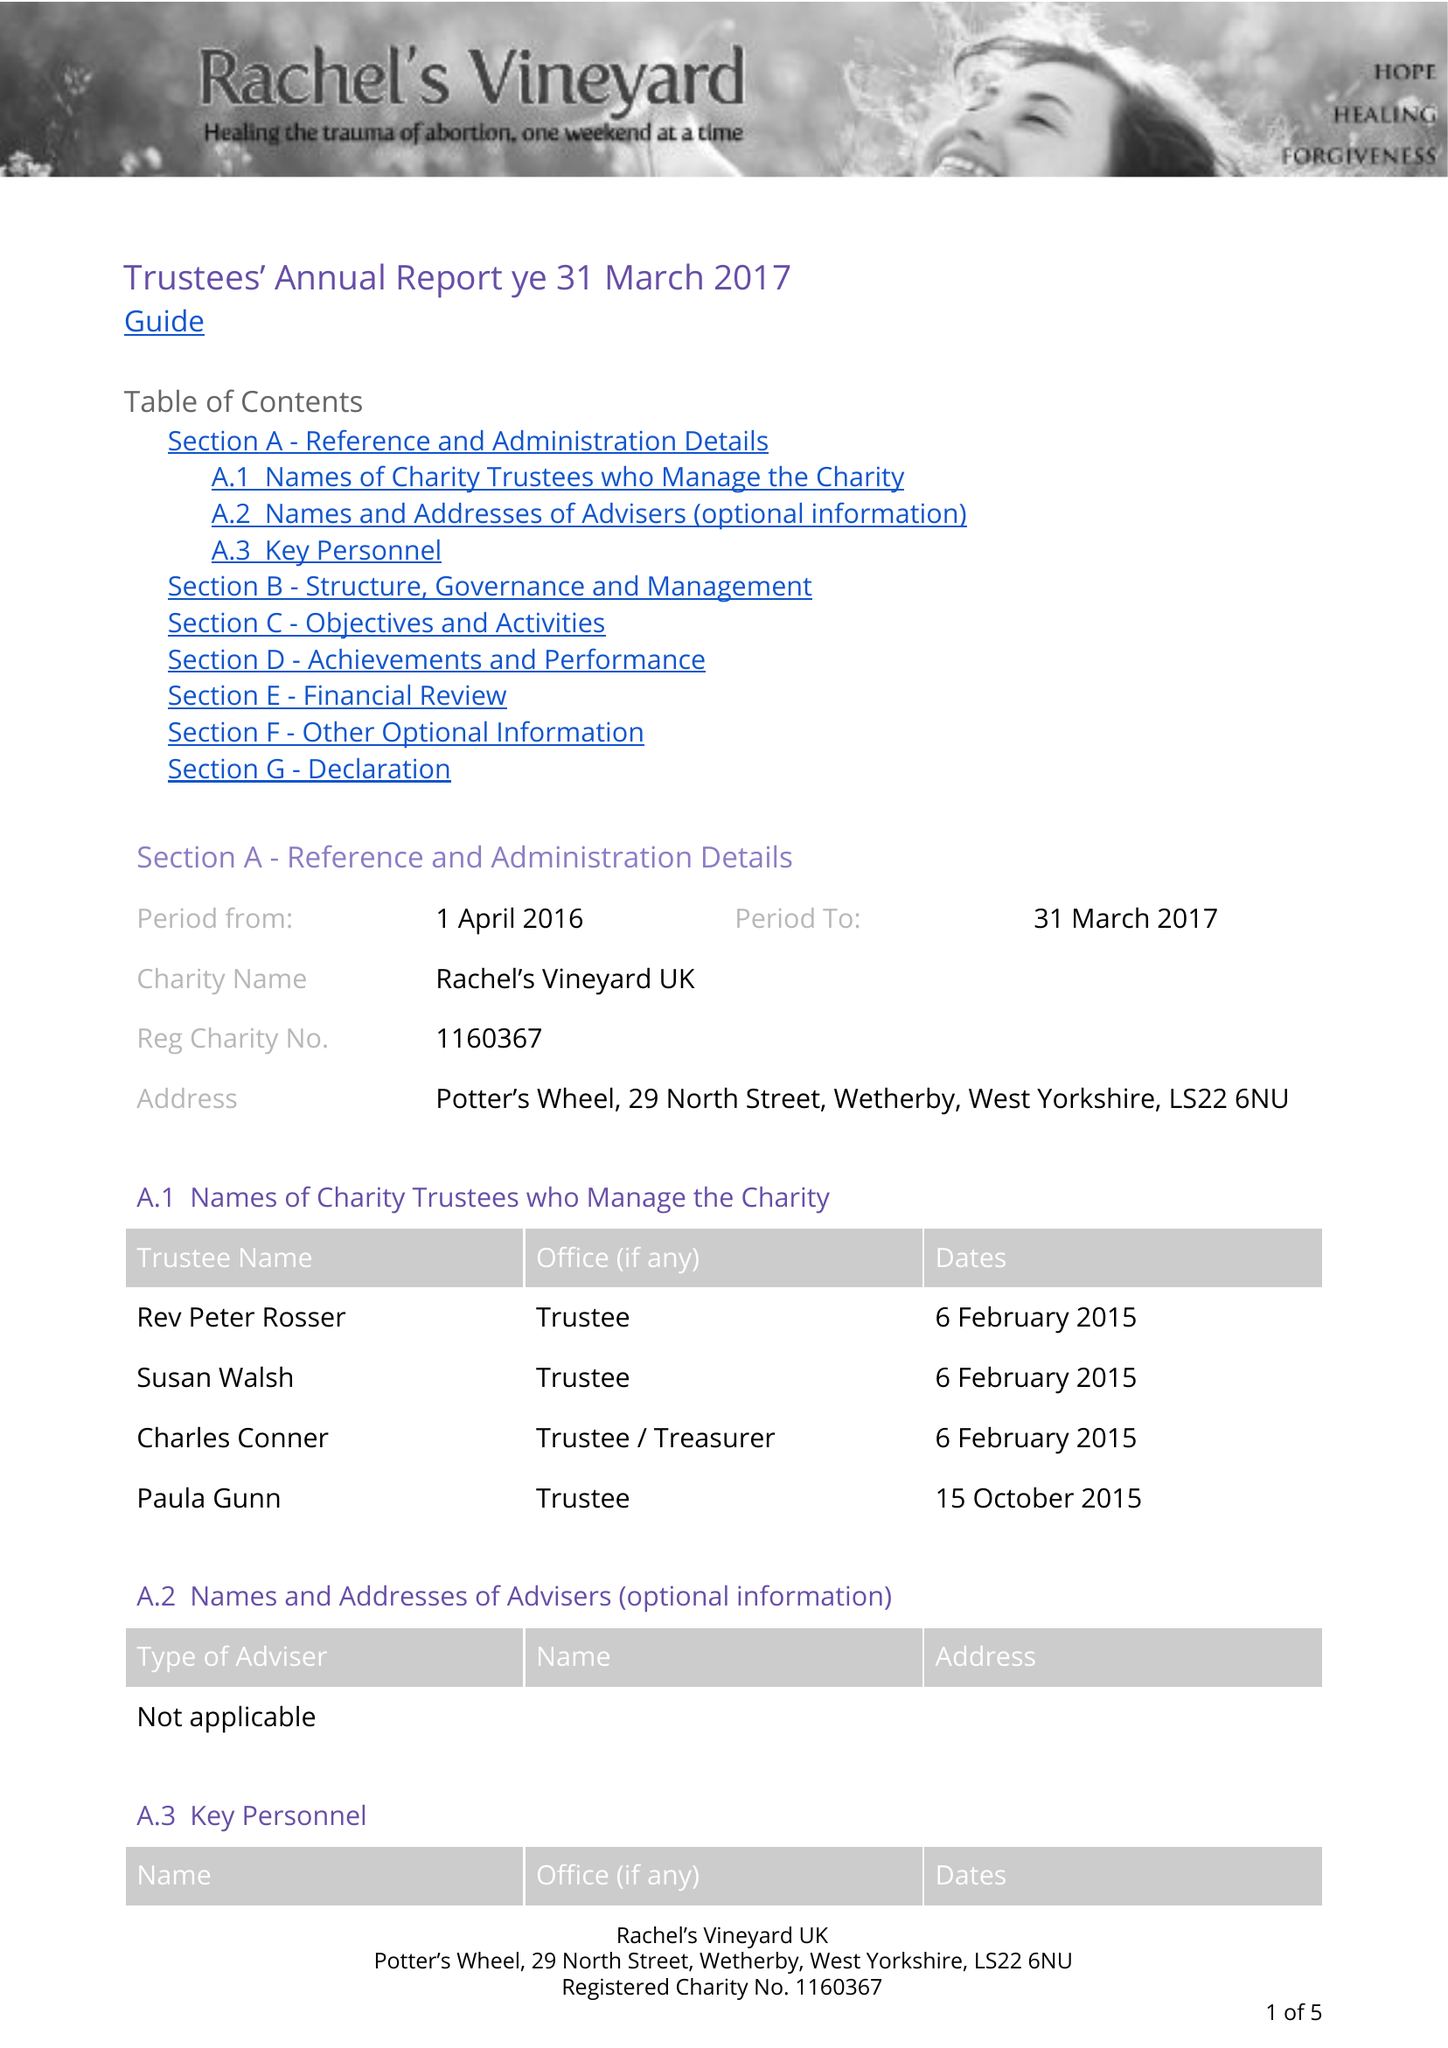What is the value for the address__post_town?
Answer the question using a single word or phrase. WETHERBY 